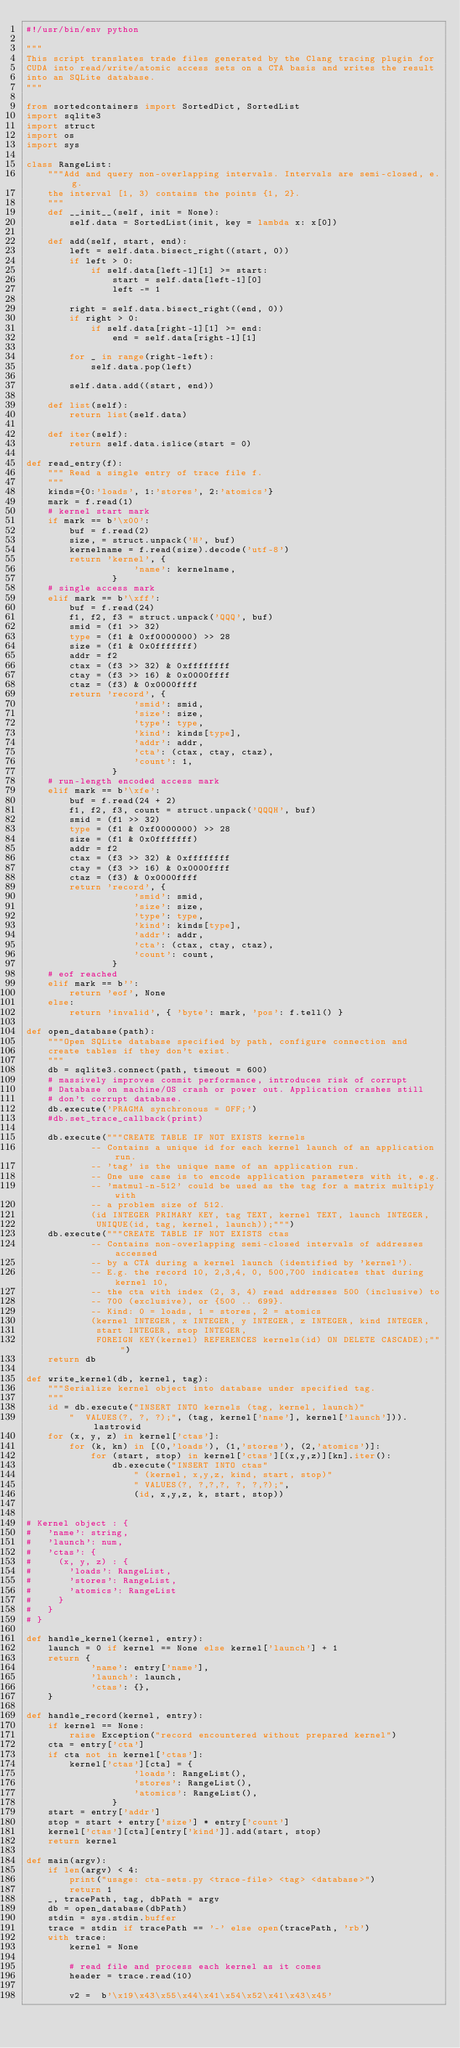Convert code to text. <code><loc_0><loc_0><loc_500><loc_500><_Python_>#!/usr/bin/env python

"""
This script translates trade files generated by the Clang tracing plugin for
CUDA into read/write/atomic access sets on a CTA basis and writes the result
into an SQLite database.
"""

from sortedcontainers import SortedDict, SortedList
import sqlite3
import struct
import os
import sys

class RangeList:
    """Add and query non-overlapping intervals. Intervals are semi-closed, e.g.
    the interval [1, 3) contains the points {1, 2}.
    """
    def __init__(self, init = None):
        self.data = SortedList(init, key = lambda x: x[0])

    def add(self, start, end):
        left = self.data.bisect_right((start, 0))
        if left > 0:
            if self.data[left-1][1] >= start:
                start = self.data[left-1][0]
                left -= 1

        right = self.data.bisect_right((end, 0))
        if right > 0:
            if self.data[right-1][1] >= end:
                end = self.data[right-1][1]

        for _ in range(right-left):
            self.data.pop(left)

        self.data.add((start, end))

    def list(self):
        return list(self.data)

    def iter(self):
        return self.data.islice(start = 0)

def read_entry(f):
    """ Read a single entry of trace file f.
    """
    kinds={0:'loads', 1:'stores', 2:'atomics'}
    mark = f.read(1)
    # kernel start mark
    if mark == b'\x00':
        buf = f.read(2)
        size, = struct.unpack('H', buf)
        kernelname = f.read(size).decode('utf-8')
        return 'kernel', {
                    'name': kernelname,
                }
    # single access mark
    elif mark == b'\xff':
        buf = f.read(24)
        f1, f2, f3 = struct.unpack('QQQ', buf)
        smid = (f1 >> 32)
        type = (f1 & 0xf0000000) >> 28
        size = (f1 & 0x0fffffff)
        addr = f2
        ctax = (f3 >> 32) & 0xffffffff
        ctay = (f3 >> 16) & 0x0000ffff
        ctaz = (f3) & 0x0000ffff
        return 'record', {
                    'smid': smid,
                    'size': size,
                    'type': type,
                    'kind': kinds[type],
                    'addr': addr,
                    'cta': (ctax, ctay, ctaz),
                    'count': 1,
                }
    # run-length encoded access mark
    elif mark == b'\xfe':
        buf = f.read(24 + 2)
        f1, f2, f3, count = struct.unpack('QQQH', buf)
        smid = (f1 >> 32)
        type = (f1 & 0xf0000000) >> 28
        size = (f1 & 0x0fffffff)
        addr = f2
        ctax = (f3 >> 32) & 0xffffffff
        ctay = (f3 >> 16) & 0x0000ffff
        ctaz = (f3) & 0x0000ffff
        return 'record', {
                    'smid': smid,
                    'size': size,
                    'type': type,
                    'kind': kinds[type],
                    'addr': addr,
                    'cta': (ctax, ctay, ctaz),
                    'count': count,
                }
    # eof reached
    elif mark == b'':
        return 'eof', None
    else:
        return 'invalid', { 'byte': mark, 'pos': f.tell() }

def open_database(path):
    """Open SQLite database specified by path, configure connection and
    create tables if they don't exist.
    """
    db = sqlite3.connect(path, timeout = 600)
    # massively improves commit performance, introduces risk of corrupt
    # Database on machine/OS crash or power out. Application crashes still
    # don't corrupt database.
    db.execute('PRAGMA synchronous = OFF;')
    #db.set_trace_callback(print)

    db.execute("""CREATE TABLE IF NOT EXISTS kernels
            -- Contains a unique id for each kernel launch of an application run.
            -- 'tag' is the unique name of an application run.
            -- One use case is to encode application parameters with it, e.g.
            -- 'matmul-n-512' could be used as the tag for a matrix multiply with
            -- a problem size of 512.
            (id INTEGER PRIMARY KEY, tag TEXT, kernel TEXT, launch INTEGER,
             UNIQUE(id, tag, kernel, launch));""")
    db.execute("""CREATE TABLE IF NOT EXISTS ctas
            -- Contains non-overlapping semi-closed intervals of addresses accessed
            -- by a CTA during a kernel launch (identified by 'kernel').
            -- E.g. the record 10, 2,3,4, 0, 500,700 indicates that during kernel 10,
            -- the cta with index (2, 3, 4) read addresses 500 (inclusive) to
            -- 700 (exclusive), or {500 .. 699}.
            -- Kind: 0 = loads, 1 = stores, 2 = atomics
            (kernel INTEGER, x INTEGER, y INTEGER, z INTEGER, kind INTEGER,
             start INTEGER, stop INTEGER,
             FOREIGN KEY(kernel) REFERENCES kernels(id) ON DELETE CASCADE);""")
    return db

def write_kernel(db, kernel, tag):
    """Serialize kernel object into database under specified tag.
    """
    id = db.execute("INSERT INTO kernels (tag, kernel, launch)"
        "  VALUES(?, ?, ?);", (tag, kernel['name'], kernel['launch'])).lastrowid
    for (x, y, z) in kernel['ctas']:
        for (k, kn) in [(0,'loads'), (1,'stores'), (2,'atomics')]:
            for (start, stop) in kernel['ctas'][(x,y,z)][kn].iter():
                db.execute("INSERT INTO ctas"
                    " (kernel, x,y,z, kind, start, stop)"
                    " VALUES(?, ?,?,?, ?, ?,?);",
                    (id, x,y,z, k, start, stop))


# Kernel object : {
#   'name': string,
#   'launch': num,
#   'ctas': {
#     (x, y, z) : {
#       'loads': RangeList,
#       'stores': RangeList,
#       'atomics': RangeList
#     }
#   }
# }

def handle_kernel(kernel, entry):
    launch = 0 if kernel == None else kernel['launch'] + 1
    return {
            'name': entry['name'],
            'launch': launch,
            'ctas': {},
    }

def handle_record(kernel, entry):
    if kernel == None:
        raise Exception("record encountered without prepared kernel")
    cta = entry['cta']
    if cta not in kernel['ctas']:
        kernel['ctas'][cta] = {
                    'loads': RangeList(),
                    'stores': RangeList(),
                    'atomics': RangeList(),
                }
    start = entry['addr']
    stop = start + entry['size'] * entry['count']
    kernel['ctas'][cta][entry['kind']].add(start, stop)
    return kernel

def main(argv):
    if len(argv) < 4:
        print("usage: cta-sets.py <trace-file> <tag> <database>")
        return 1
    _, tracePath, tag, dbPath = argv
    db = open_database(dbPath)
    stdin = sys.stdin.buffer
    trace = stdin if tracePath == '-' else open(tracePath, 'rb')
    with trace:
        kernel = None 

        # read file and process each kernel as it comes
        header = trace.read(10)

        v2 =  b'\x19\x43\x55\x44\x41\x54\x52\x41\x43\x45'</code> 